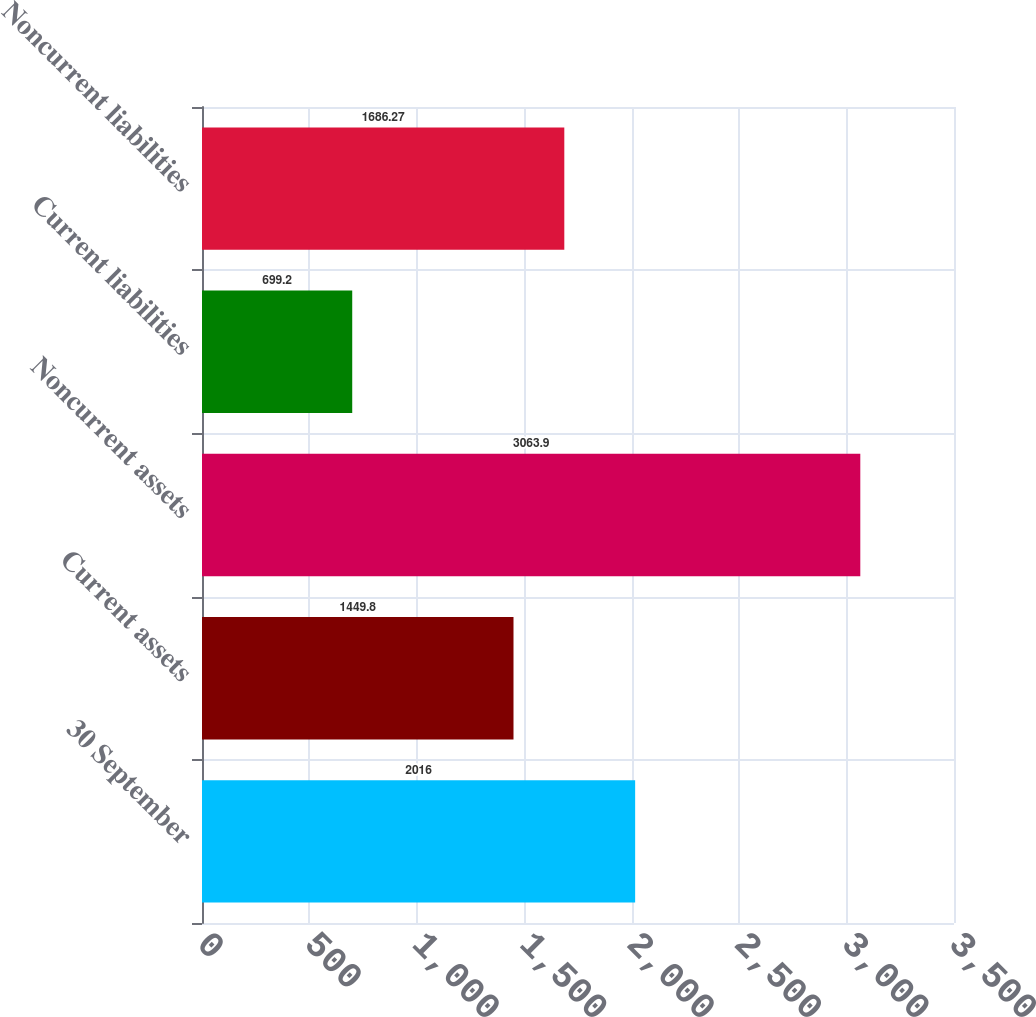Convert chart. <chart><loc_0><loc_0><loc_500><loc_500><bar_chart><fcel>30 September<fcel>Current assets<fcel>Noncurrent assets<fcel>Current liabilities<fcel>Noncurrent liabilities<nl><fcel>2016<fcel>1449.8<fcel>3063.9<fcel>699.2<fcel>1686.27<nl></chart> 